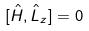Convert formula to latex. <formula><loc_0><loc_0><loc_500><loc_500>[ \hat { H } , \hat { L } _ { z } ] = 0</formula> 